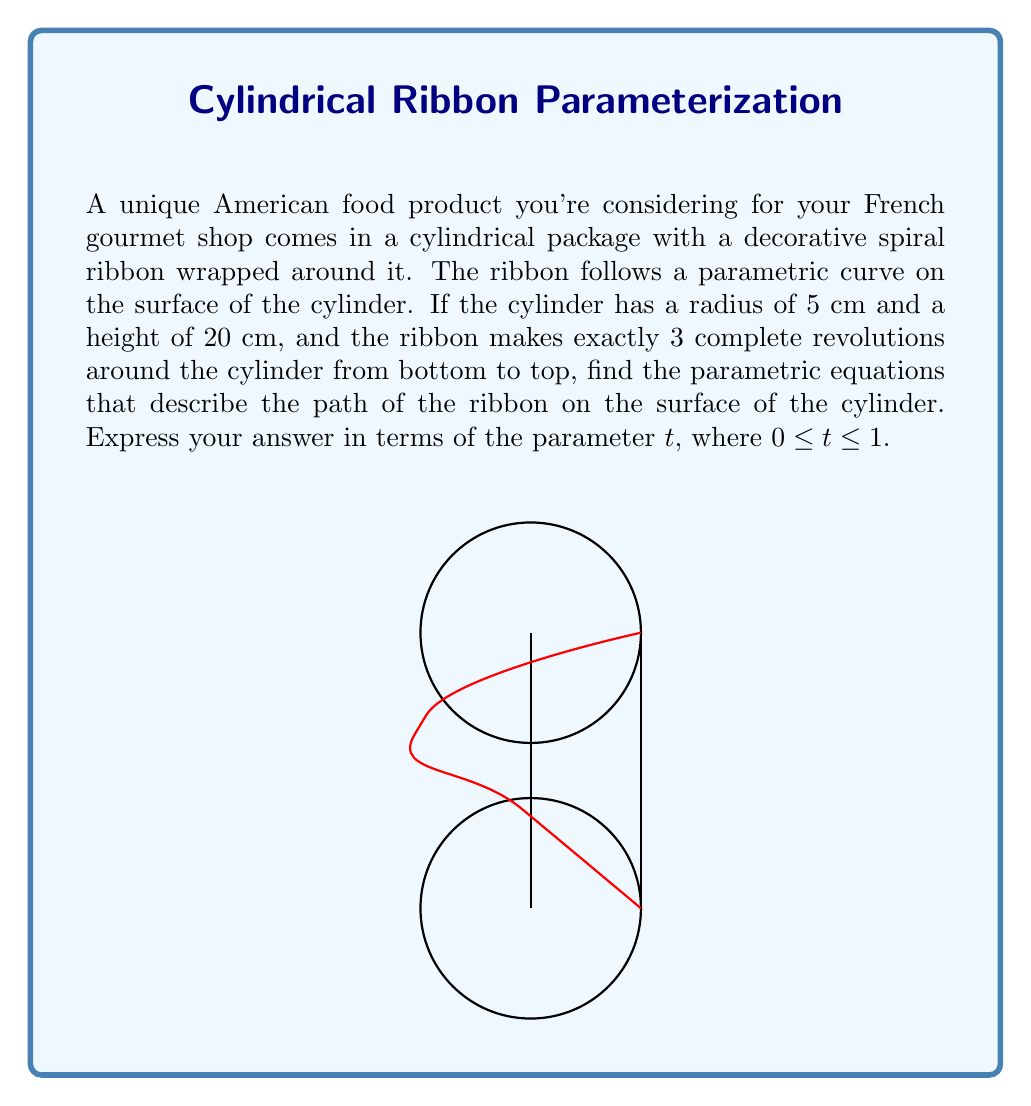Can you answer this question? Let's approach this step-by-step:

1) First, we need to understand what the parametric equations for a cylinder look like. Generally, they are:

   $x = r \cos(\theta)$
   $y = r \sin(\theta)$
   $z = h$

   Where $r$ is the radius, $h$ is the height, and $\theta$ is the angle of rotation.

2) In our case, $r = 5$ cm and the total height is 20 cm.

3) Now, we need to consider how the ribbon wraps around the cylinder. It makes 3 complete revolutions from bottom to top. This means:

   - When $t = 0$, we're at the bottom of the cylinder ($z = 0$) and at some point on the circular base.
   - When $t = 1$, we're at the top of the cylinder ($z = 20$) and we've rotated 3 full times ($6\pi$ radians).

4) Let's construct our equations:

   For $x$ and $y$:
   - The angle of rotation $\theta$ goes from 0 to $6\pi$ as $t$ goes from 0 to 1.
   - So, $\theta = 6\pi t$

   $x = 5 \cos(6\pi t)$
   $y = 5 \sin(6\pi t)$

   For $z$:
   - $z$ goes from 0 to 20 linearly as $t$ goes from 0 to 1.
   
   $z = 20t$

5) Therefore, our parametric equations are:

   $x = 5 \cos(6\pi t)$
   $y = 5 \sin(6\pi t)$
   $z = 20t$

   Where $0 \leq t \leq 1$
Answer: $$x = 5 \cos(6\pi t), \quad y = 5 \sin(6\pi t), \quad z = 20t, \quad 0 \leq t \leq 1$$ 